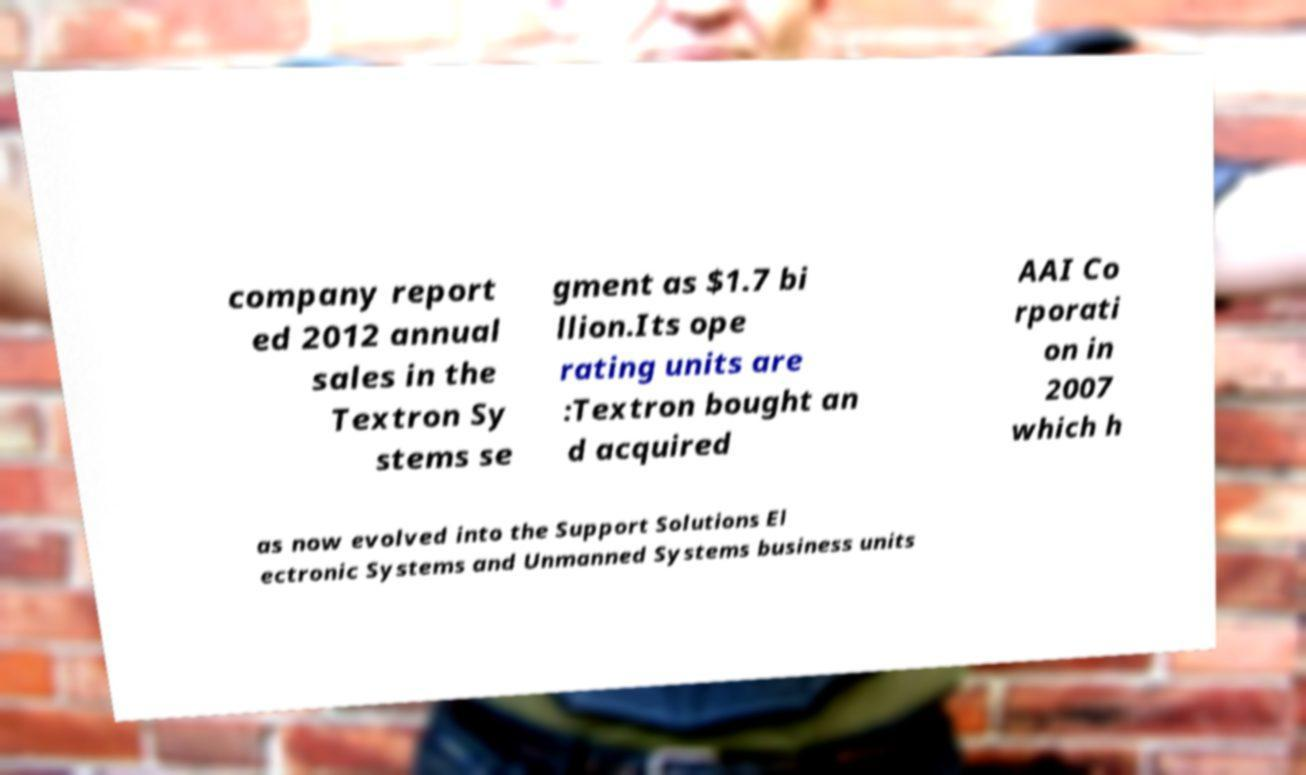Please identify and transcribe the text found in this image. company report ed 2012 annual sales in the Textron Sy stems se gment as $1.7 bi llion.Its ope rating units are :Textron bought an d acquired AAI Co rporati on in 2007 which h as now evolved into the Support Solutions El ectronic Systems and Unmanned Systems business units 